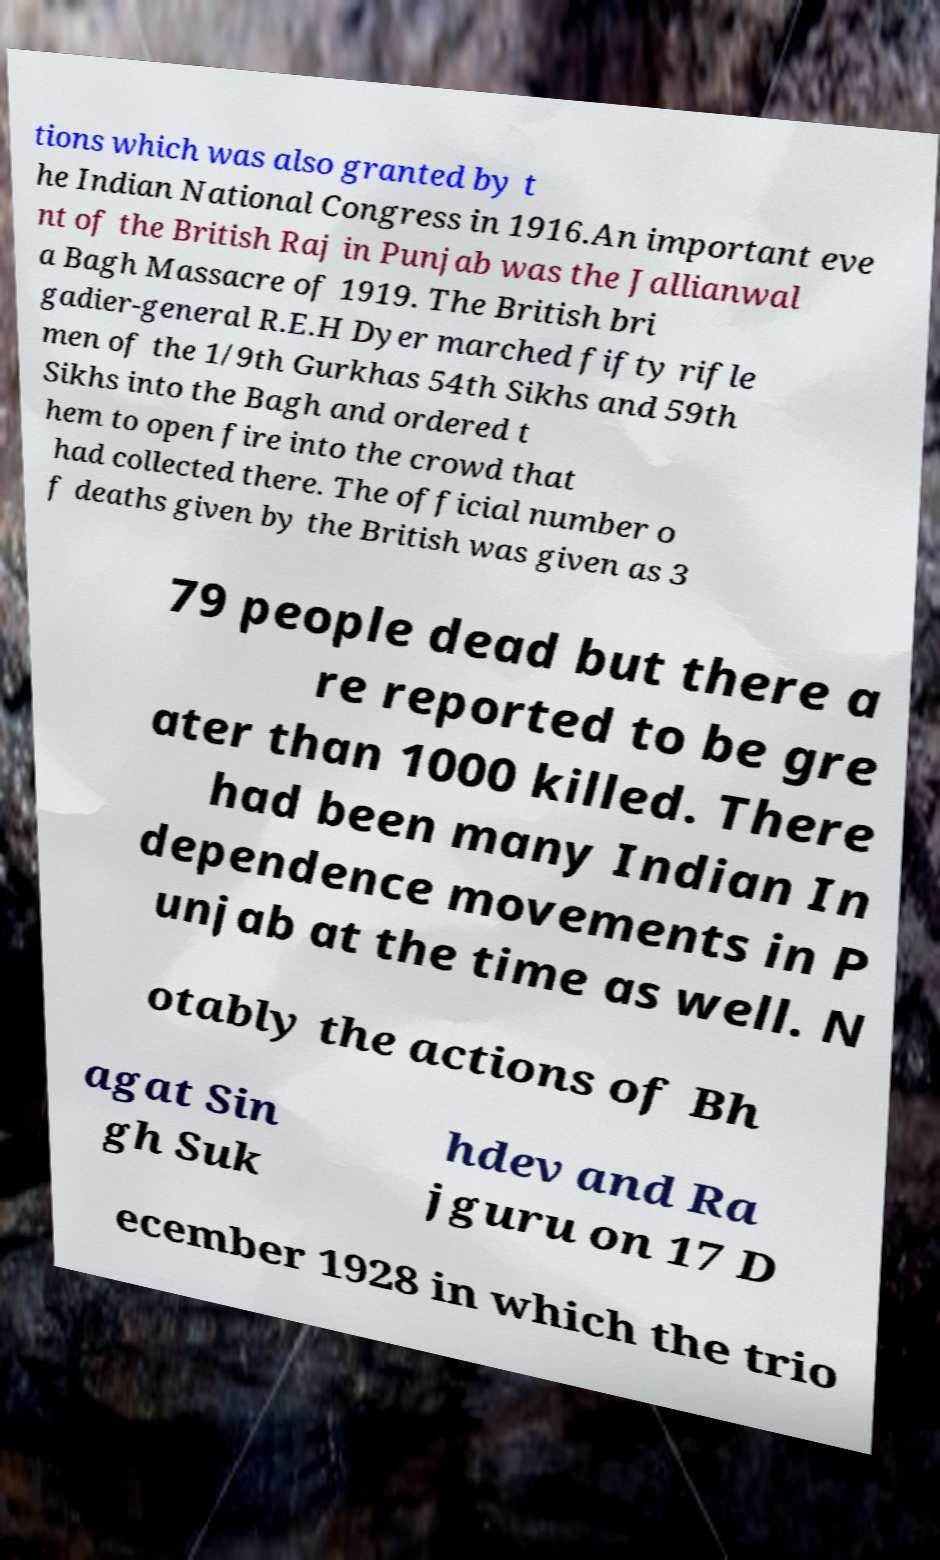There's text embedded in this image that I need extracted. Can you transcribe it verbatim? tions which was also granted by t he Indian National Congress in 1916.An important eve nt of the British Raj in Punjab was the Jallianwal a Bagh Massacre of 1919. The British bri gadier-general R.E.H Dyer marched fifty rifle men of the 1/9th Gurkhas 54th Sikhs and 59th Sikhs into the Bagh and ordered t hem to open fire into the crowd that had collected there. The official number o f deaths given by the British was given as 3 79 people dead but there a re reported to be gre ater than 1000 killed. There had been many Indian In dependence movements in P unjab at the time as well. N otably the actions of Bh agat Sin gh Suk hdev and Ra jguru on 17 D ecember 1928 in which the trio 